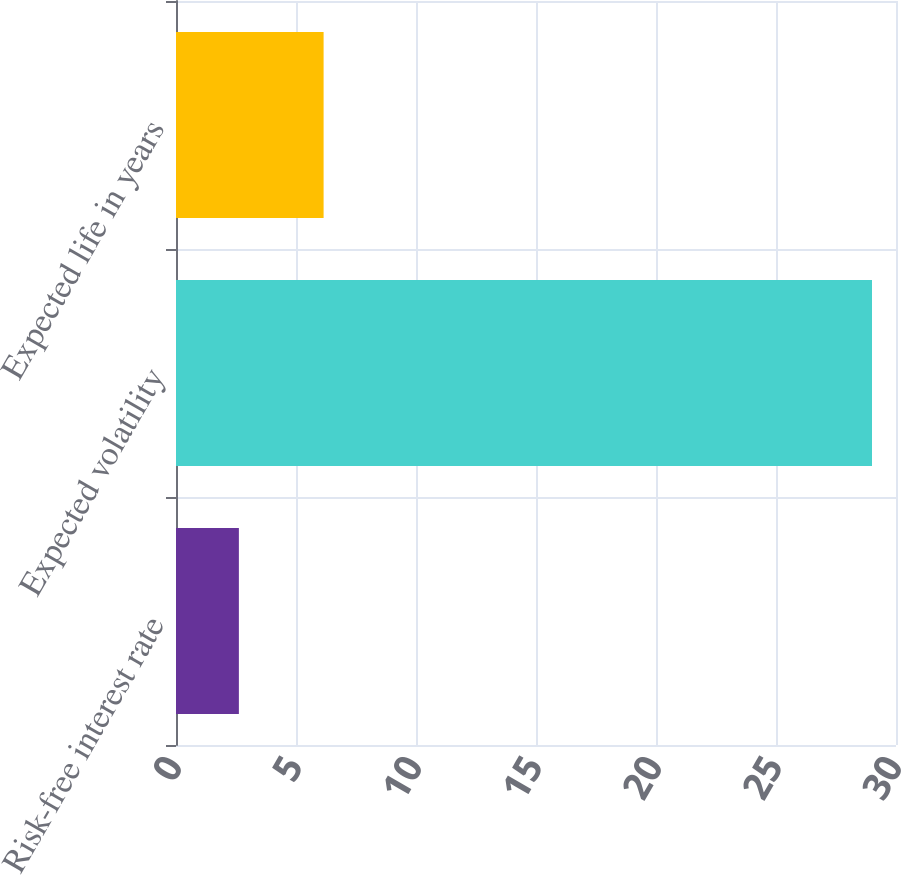Convert chart to OTSL. <chart><loc_0><loc_0><loc_500><loc_500><bar_chart><fcel>Risk-free interest rate<fcel>Expected volatility<fcel>Expected life in years<nl><fcel>2.62<fcel>29<fcel>6.15<nl></chart> 